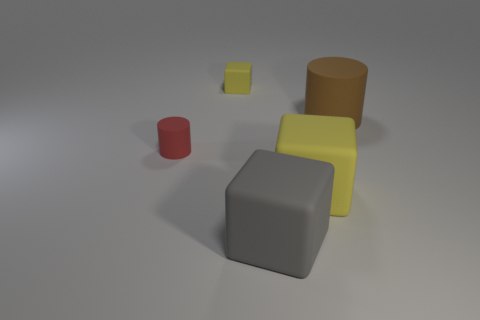How do the textures of the objects compare? The textures of the objects vary; the grey cube in the foreground has a matte finish, which diffuses light and makes its surface appear smooth. The yellow cube also has a matte texture with a slightly reflective sheen, which indicates it might be made of a different material. The brown cylinder appears to have a rough, possibly rubber-like texture, whereas the red cylinder has a more vibrant hue with a similar matte appearance. Which object seems out of place in this group and why? If we were to select an object that seems most out of place, it might be the small yellow cube to the right of the grey cube. This is because it has the brightest color, which contrasts with the more subdued tones of the other objects in the scene. 